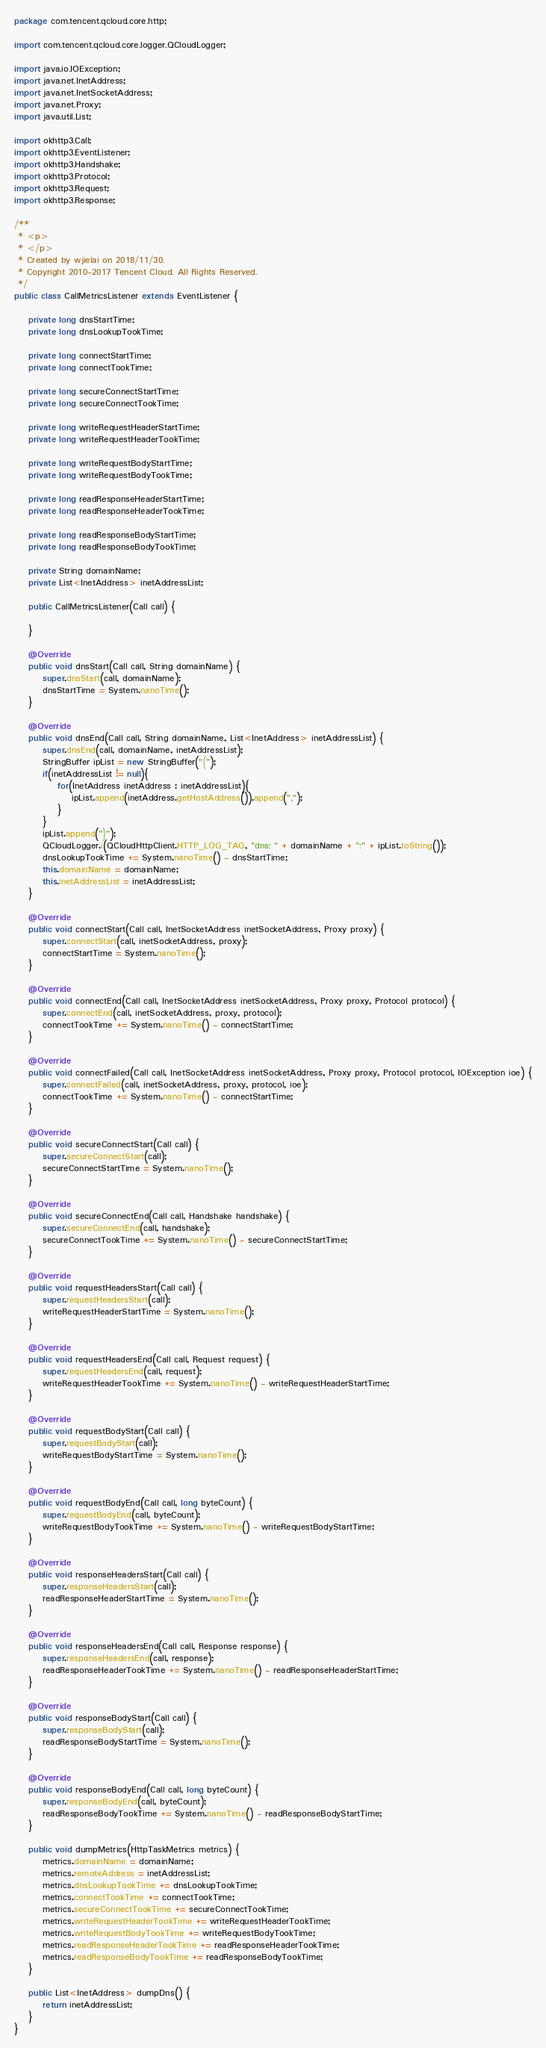<code> <loc_0><loc_0><loc_500><loc_500><_Java_>package com.tencent.qcloud.core.http;

import com.tencent.qcloud.core.logger.QCloudLogger;

import java.io.IOException;
import java.net.InetAddress;
import java.net.InetSocketAddress;
import java.net.Proxy;
import java.util.List;

import okhttp3.Call;
import okhttp3.EventListener;
import okhttp3.Handshake;
import okhttp3.Protocol;
import okhttp3.Request;
import okhttp3.Response;

/**
 * <p>
 * </p>
 * Created by wjielai on 2018/11/30.
 * Copyright 2010-2017 Tencent Cloud. All Rights Reserved.
 */
public class CallMetricsListener extends EventListener {

    private long dnsStartTime;
    private long dnsLookupTookTime;

    private long connectStartTime;
    private long connectTookTime;

    private long secureConnectStartTime;
    private long secureConnectTookTime;

    private long writeRequestHeaderStartTime;
    private long writeRequestHeaderTookTime;

    private long writeRequestBodyStartTime;
    private long writeRequestBodyTookTime;

    private long readResponseHeaderStartTime;
    private long readResponseHeaderTookTime;

    private long readResponseBodyStartTime;
    private long readResponseBodyTookTime;

    private String domainName;
    private List<InetAddress> inetAddressList;

    public CallMetricsListener(Call call) {

    }

    @Override
    public void dnsStart(Call call, String domainName) {
        super.dnsStart(call, domainName);
        dnsStartTime = System.nanoTime();
    }

    @Override
    public void dnsEnd(Call call, String domainName, List<InetAddress> inetAddressList) {
        super.dnsEnd(call, domainName, inetAddressList);
        StringBuffer ipList = new StringBuffer("{");
        if(inetAddressList != null){
            for(InetAddress inetAddress : inetAddressList){
                ipList.append(inetAddress.getHostAddress()).append(",");
            }
        }
        ipList.append("}");
        QCloudLogger.i(QCloudHttpClient.HTTP_LOG_TAG, "dns: " + domainName + ":" + ipList.toString());
        dnsLookupTookTime += System.nanoTime() - dnsStartTime;
        this.domainName = domainName;
        this.inetAddressList = inetAddressList;
    }

    @Override
    public void connectStart(Call call, InetSocketAddress inetSocketAddress, Proxy proxy) {
        super.connectStart(call, inetSocketAddress, proxy);
        connectStartTime = System.nanoTime();
    }

    @Override
    public void connectEnd(Call call, InetSocketAddress inetSocketAddress, Proxy proxy, Protocol protocol) {
        super.connectEnd(call, inetSocketAddress, proxy, protocol);
        connectTookTime += System.nanoTime() - connectStartTime;
    }

    @Override
    public void connectFailed(Call call, InetSocketAddress inetSocketAddress, Proxy proxy, Protocol protocol, IOException ioe) {
        super.connectFailed(call, inetSocketAddress, proxy, protocol, ioe);
        connectTookTime += System.nanoTime() - connectStartTime;
    }

    @Override
    public void secureConnectStart(Call call) {
        super.secureConnectStart(call);
        secureConnectStartTime = System.nanoTime();
    }

    @Override
    public void secureConnectEnd(Call call, Handshake handshake) {
        super.secureConnectEnd(call, handshake);
        secureConnectTookTime += System.nanoTime() - secureConnectStartTime;
    }

    @Override
    public void requestHeadersStart(Call call) {
        super.requestHeadersStart(call);
        writeRequestHeaderStartTime = System.nanoTime();
    }

    @Override
    public void requestHeadersEnd(Call call, Request request) {
        super.requestHeadersEnd(call, request);
        writeRequestHeaderTookTime += System.nanoTime() - writeRequestHeaderStartTime;
    }

    @Override
    public void requestBodyStart(Call call) {
        super.requestBodyStart(call);
        writeRequestBodyStartTime = System.nanoTime();
    }

    @Override
    public void requestBodyEnd(Call call, long byteCount) {
        super.requestBodyEnd(call, byteCount);
        writeRequestBodyTookTime += System.nanoTime() - writeRequestBodyStartTime;
    }

    @Override
    public void responseHeadersStart(Call call) {
        super.responseHeadersStart(call);
        readResponseHeaderStartTime = System.nanoTime();
    }

    @Override
    public void responseHeadersEnd(Call call, Response response) {
        super.responseHeadersEnd(call, response);
        readResponseHeaderTookTime += System.nanoTime() - readResponseHeaderStartTime;
    }

    @Override
    public void responseBodyStart(Call call) {
        super.responseBodyStart(call);
        readResponseBodyStartTime = System.nanoTime();
    }

    @Override
    public void responseBodyEnd(Call call, long byteCount) {
        super.responseBodyEnd(call, byteCount);
        readResponseBodyTookTime += System.nanoTime() - readResponseBodyStartTime;
    }

    public void dumpMetrics(HttpTaskMetrics metrics) {
        metrics.domainName = domainName;
        metrics.remoteAddress = inetAddressList;
        metrics.dnsLookupTookTime += dnsLookupTookTime;
        metrics.connectTookTime += connectTookTime;
        metrics.secureConnectTookTime += secureConnectTookTime;
        metrics.writeRequestHeaderTookTime += writeRequestHeaderTookTime;
        metrics.writeRequestBodyTookTime += writeRequestBodyTookTime;
        metrics.readResponseHeaderTookTime += readResponseHeaderTookTime;
        metrics.readResponseBodyTookTime += readResponseBodyTookTime;
    }

    public List<InetAddress> dumpDns() {
        return inetAddressList;
    }
}
</code> 